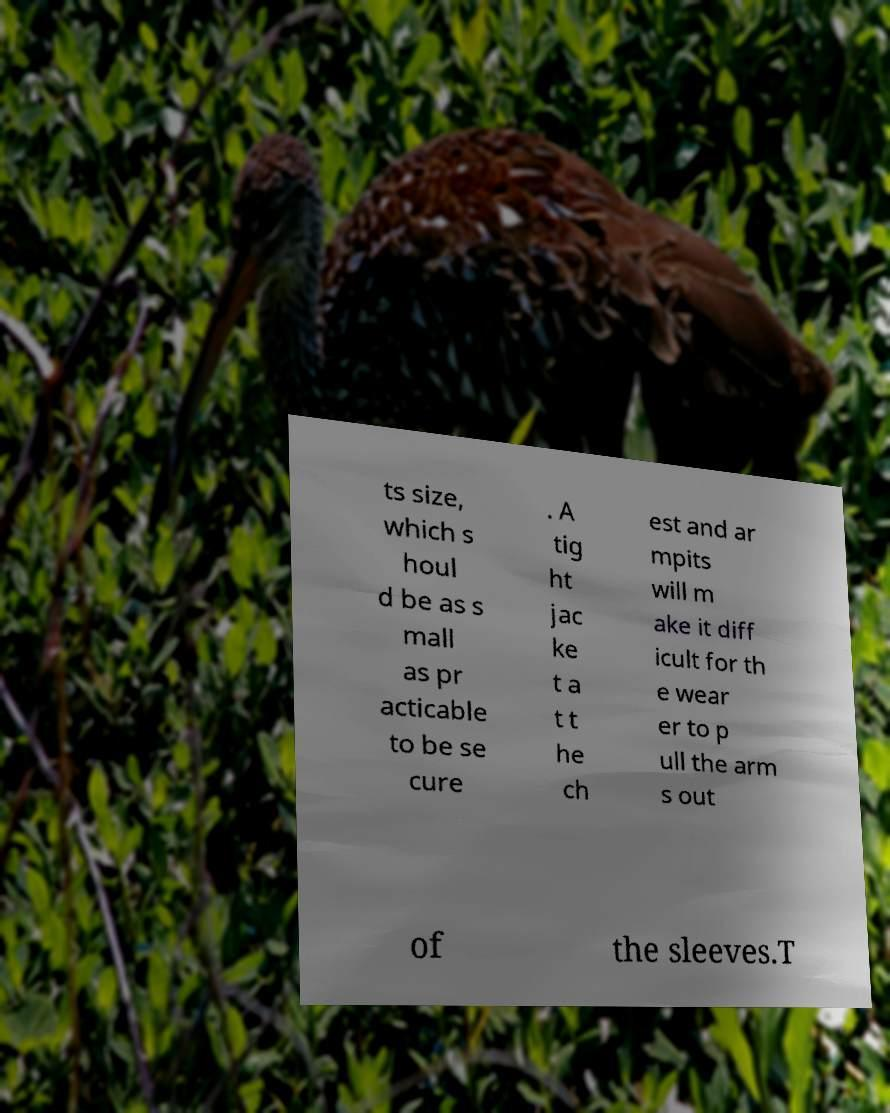Can you read and provide the text displayed in the image?This photo seems to have some interesting text. Can you extract and type it out for me? ts size, which s houl d be as s mall as pr acticable to be se cure . A tig ht jac ke t a t t he ch est and ar mpits will m ake it diff icult for th e wear er to p ull the arm s out of the sleeves.T 